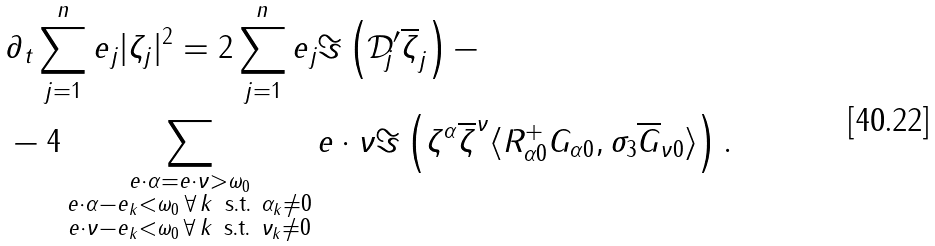<formula> <loc_0><loc_0><loc_500><loc_500>& \partial _ { t } \sum _ { j = 1 } ^ { n } e _ { j } | \zeta _ { j } | ^ { 2 } = 2 \sum _ { j = 1 } ^ { n } e _ { j } \Im \left ( \mathcal { D } _ { j } ^ { \prime } \overline { \zeta } _ { j } \right ) - \\ & - 4 \sum _ { \substack { e \cdot \alpha = e \cdot \nu > \omega _ { 0 } \\ e \cdot \alpha - e _ { k } < \omega _ { 0 } \, \forall \, k \, \text { s.t. } \alpha _ { k } \neq 0 \\ e \cdot \nu - e _ { k } < \omega _ { 0 } \, \forall \, k \, \text { s.t. } \nu _ { k } \neq 0 } } e \cdot \nu \Im \left ( \zeta ^ { \alpha } \overline { \zeta } ^ { \nu } \langle R _ { \alpha 0 } ^ { + } G _ { \alpha 0 } , \sigma _ { 3 } \overline { G } _ { \nu 0 } \rangle \right ) .</formula> 